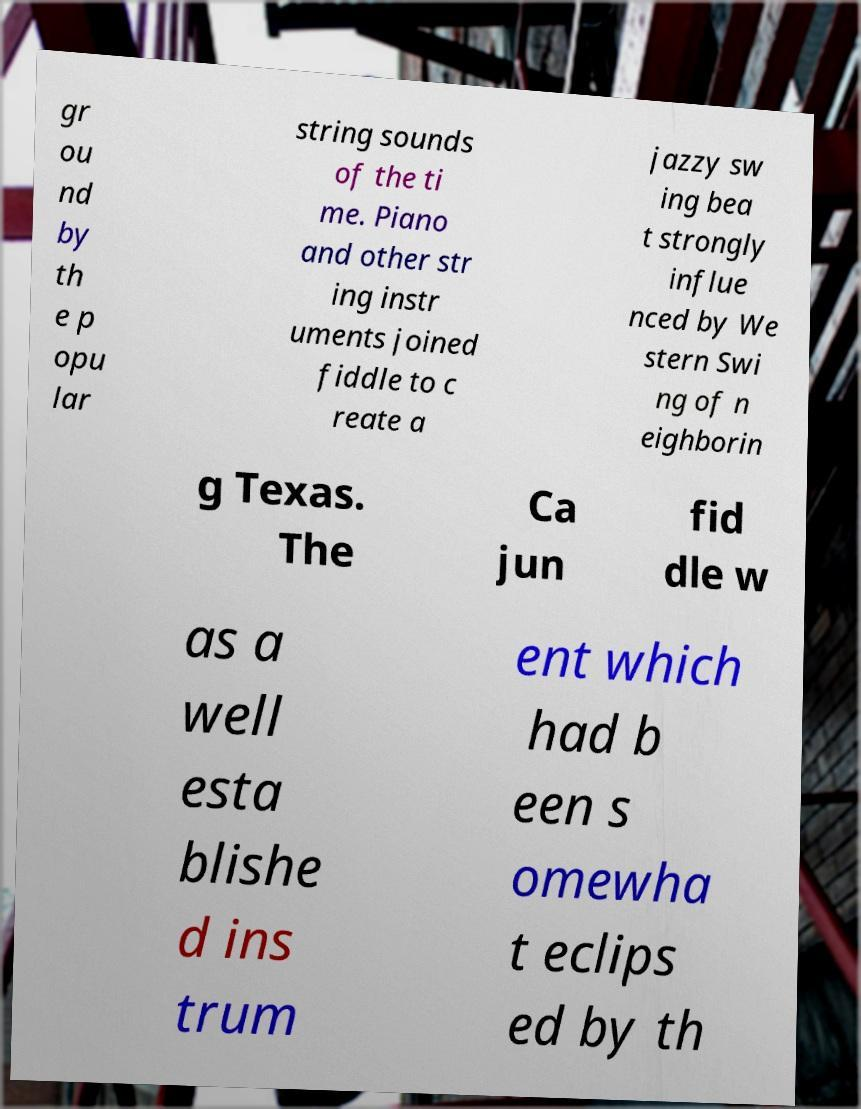Please read and relay the text visible in this image. What does it say? gr ou nd by th e p opu lar string sounds of the ti me. Piano and other str ing instr uments joined fiddle to c reate a jazzy sw ing bea t strongly influe nced by We stern Swi ng of n eighborin g Texas. The Ca jun fid dle w as a well esta blishe d ins trum ent which had b een s omewha t eclips ed by th 